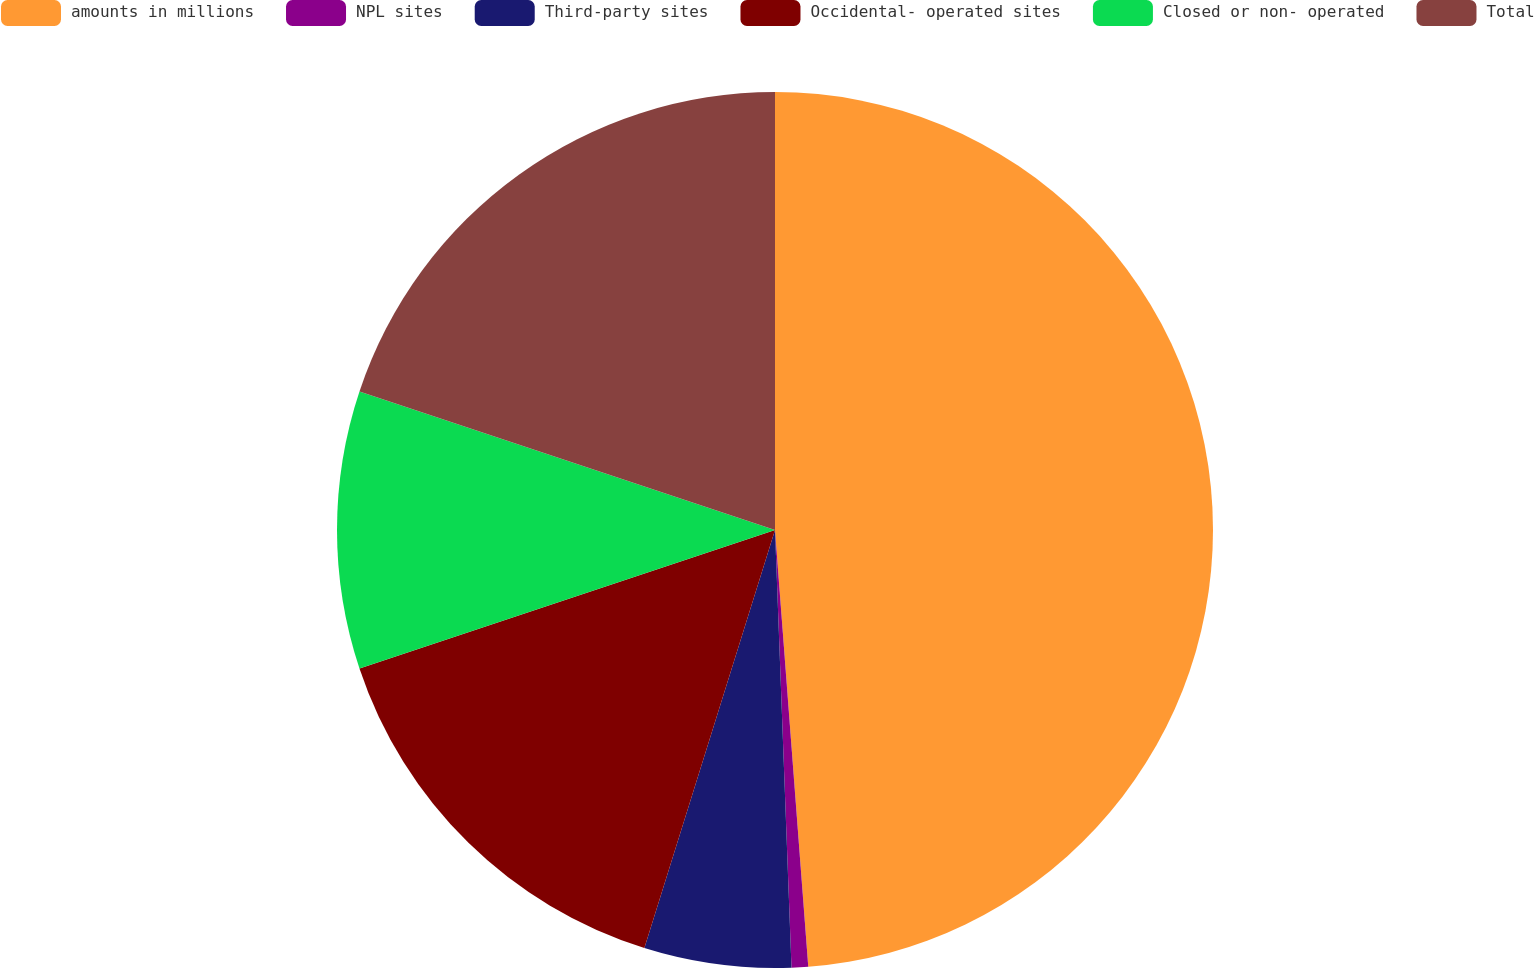Convert chart to OTSL. <chart><loc_0><loc_0><loc_500><loc_500><pie_chart><fcel>amounts in millions<fcel>NPL sites<fcel>Third-party sites<fcel>Occidental- operated sites<fcel>Closed or non- operated<fcel>Total<nl><fcel>48.79%<fcel>0.61%<fcel>5.42%<fcel>15.06%<fcel>10.24%<fcel>19.88%<nl></chart> 